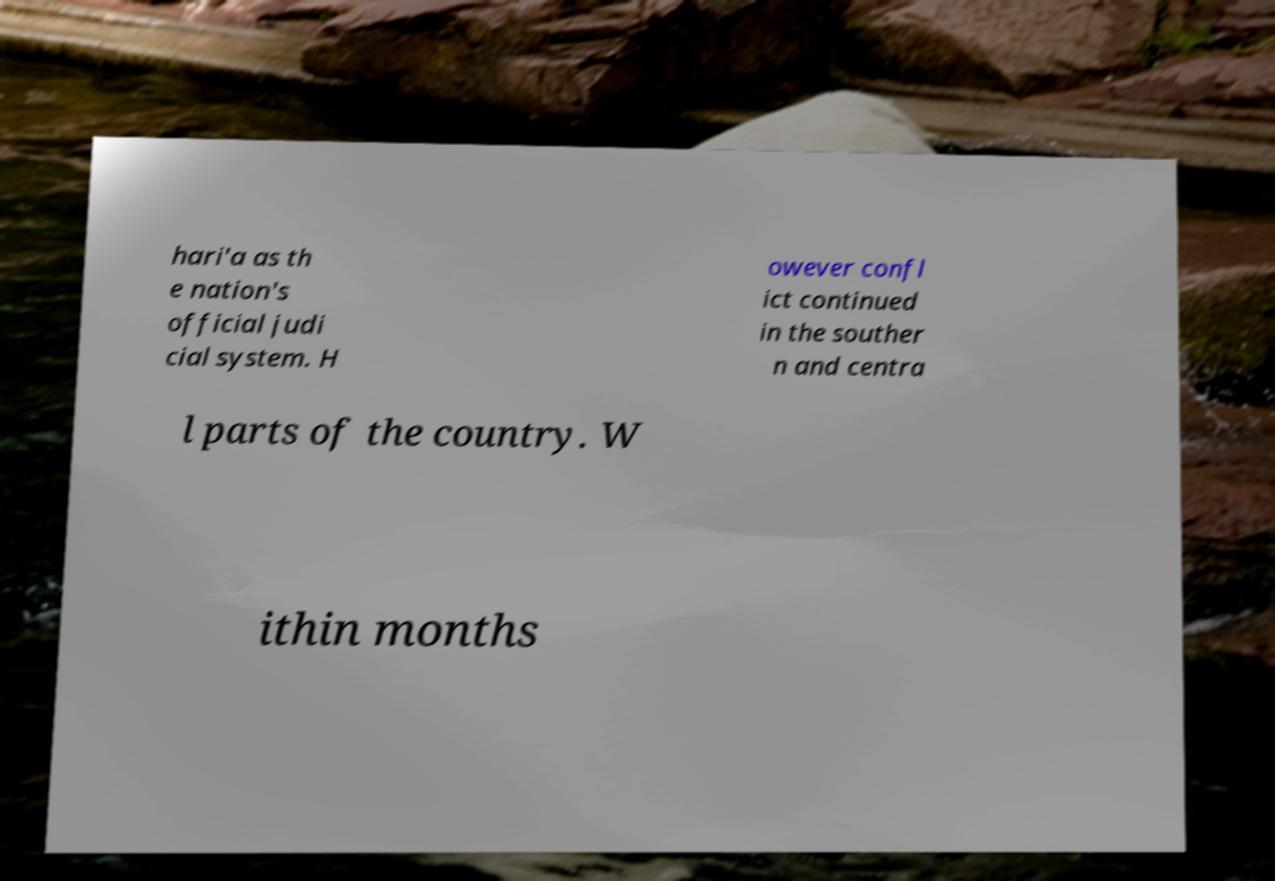There's text embedded in this image that I need extracted. Can you transcribe it verbatim? hari'a as th e nation's official judi cial system. H owever confl ict continued in the souther n and centra l parts of the country. W ithin months 